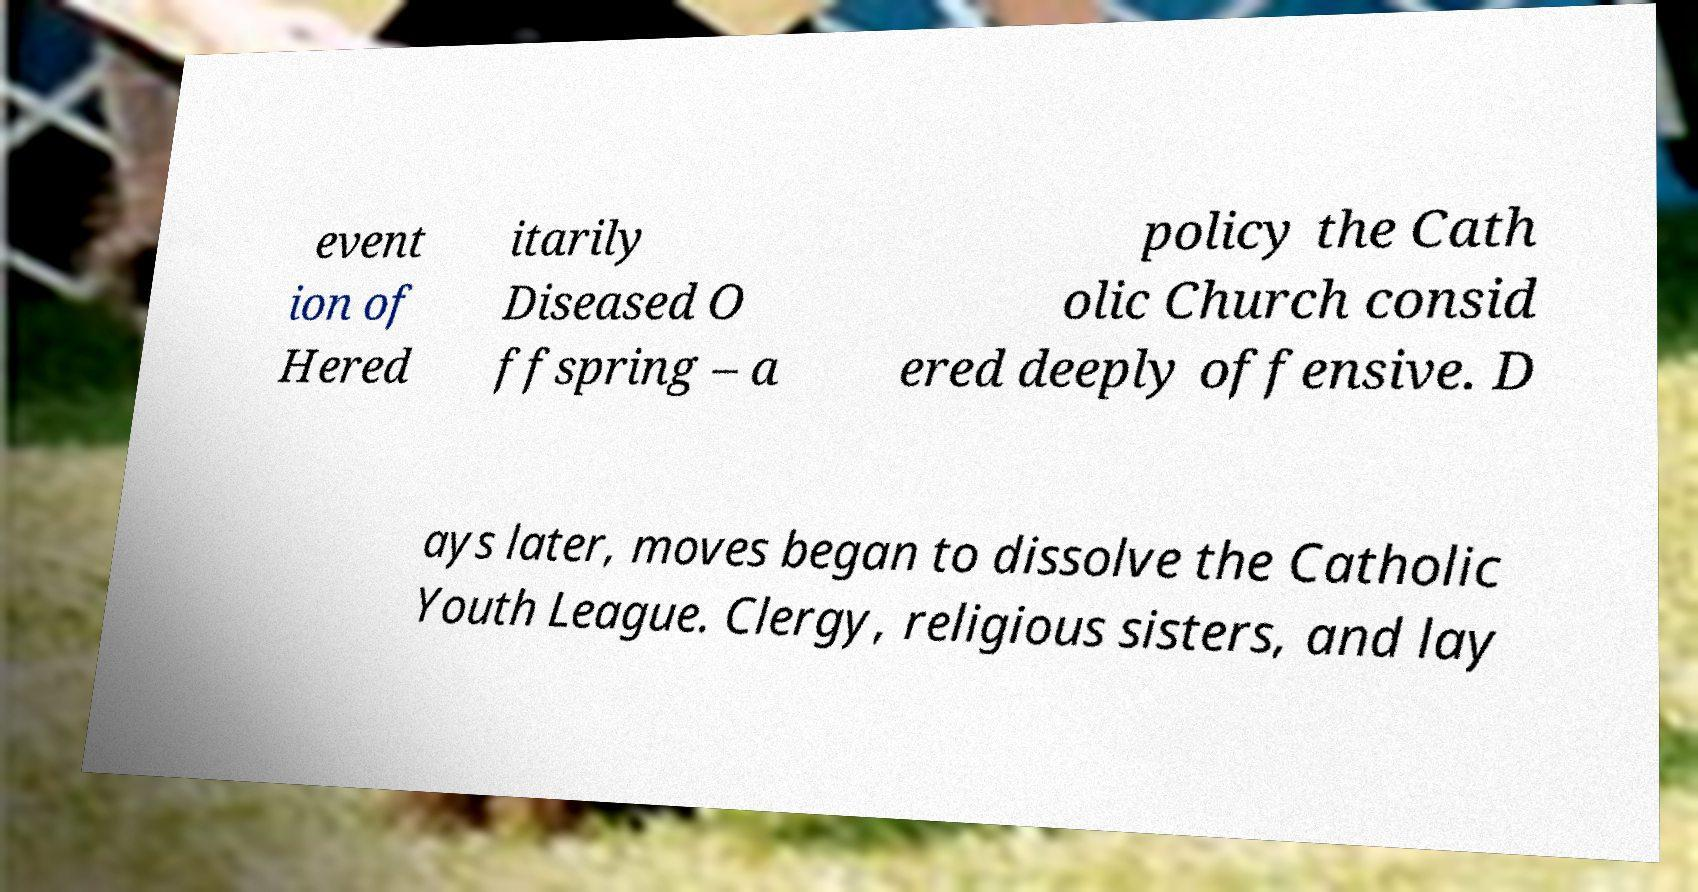What messages or text are displayed in this image? I need them in a readable, typed format. event ion of Hered itarily Diseased O ffspring – a policy the Cath olic Church consid ered deeply offensive. D ays later, moves began to dissolve the Catholic Youth League. Clergy, religious sisters, and lay 